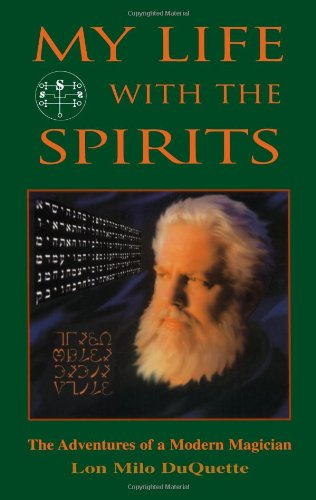Is this a life story book? Yes, this book is a biographical narrative where Lon Milo DuQuette shares his adventures and encounters, offering a personal glimpse into his life as a modern magician. 